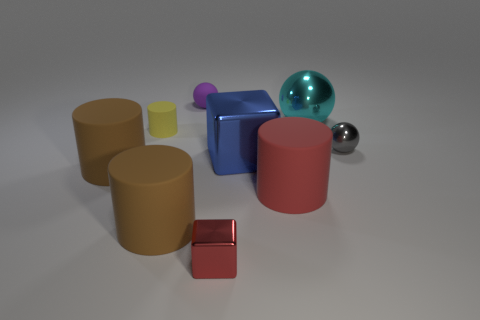How many brown cylinders must be subtracted to get 1 brown cylinders? 1 Subtract all green cylinders. Subtract all purple blocks. How many cylinders are left? 4 Subtract all balls. How many objects are left? 6 Subtract all cyan things. Subtract all tiny matte cylinders. How many objects are left? 7 Add 1 big rubber objects. How many big rubber objects are left? 4 Add 1 small cyan metallic cylinders. How many small cyan metallic cylinders exist? 1 Subtract 1 red cubes. How many objects are left? 8 